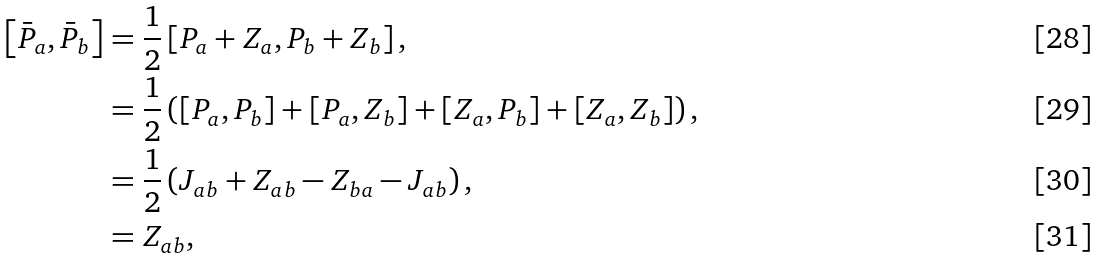<formula> <loc_0><loc_0><loc_500><loc_500>\left [ \bar { P } _ { a } , \bar { P } _ { b } \right ] & = \frac { 1 } { 2 } \left [ P _ { a } + Z _ { a } , P _ { b } + Z _ { b } \right ] , \\ & = \frac { 1 } { 2 } \left ( \left [ P _ { a } , P _ { b } \right ] + \left [ P _ { a } , Z _ { b } \right ] + \left [ Z _ { a } , P _ { b } \right ] + \left [ Z _ { a } , Z _ { b } \right ] \right ) , \\ & = \frac { 1 } { 2 } \left ( J _ { a b } + Z _ { a b } - Z _ { b a } - J _ { a b } \right ) , \\ & = Z _ { a b } ,</formula> 